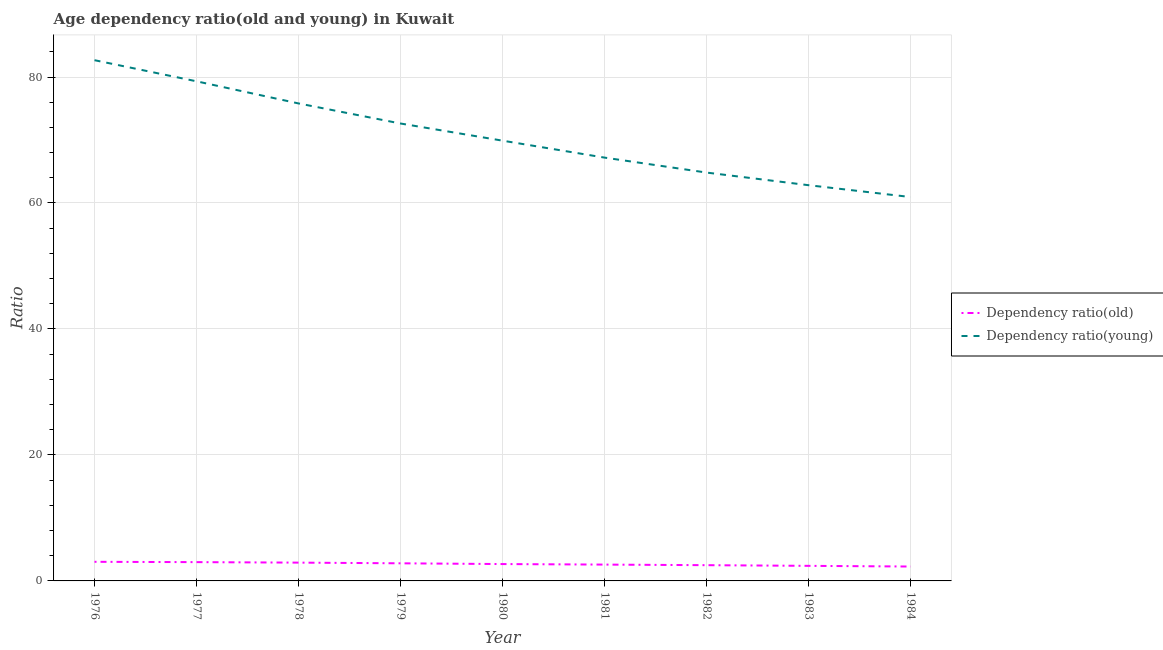How many different coloured lines are there?
Provide a short and direct response. 2. Does the line corresponding to age dependency ratio(old) intersect with the line corresponding to age dependency ratio(young)?
Your answer should be very brief. No. Is the number of lines equal to the number of legend labels?
Your answer should be very brief. Yes. What is the age dependency ratio(old) in 1978?
Your answer should be compact. 2.9. Across all years, what is the maximum age dependency ratio(young)?
Provide a short and direct response. 82.67. Across all years, what is the minimum age dependency ratio(old)?
Offer a very short reply. 2.28. In which year was the age dependency ratio(young) maximum?
Keep it short and to the point. 1976. What is the total age dependency ratio(old) in the graph?
Ensure brevity in your answer.  24.17. What is the difference between the age dependency ratio(old) in 1976 and that in 1982?
Ensure brevity in your answer.  0.54. What is the difference between the age dependency ratio(old) in 1979 and the age dependency ratio(young) in 1982?
Offer a very short reply. -62.03. What is the average age dependency ratio(young) per year?
Ensure brevity in your answer.  70.68. In the year 1983, what is the difference between the age dependency ratio(young) and age dependency ratio(old)?
Your answer should be very brief. 60.43. What is the ratio of the age dependency ratio(old) in 1979 to that in 1981?
Your answer should be compact. 1.08. Is the difference between the age dependency ratio(old) in 1981 and 1982 greater than the difference between the age dependency ratio(young) in 1981 and 1982?
Keep it short and to the point. No. What is the difference between the highest and the second highest age dependency ratio(old)?
Your answer should be compact. 0.05. What is the difference between the highest and the lowest age dependency ratio(old)?
Offer a terse response. 0.75. Is the age dependency ratio(old) strictly less than the age dependency ratio(young) over the years?
Provide a succinct answer. Yes. How many lines are there?
Offer a terse response. 2. How many years are there in the graph?
Your answer should be compact. 9. What is the difference between two consecutive major ticks on the Y-axis?
Your answer should be compact. 20. Are the values on the major ticks of Y-axis written in scientific E-notation?
Make the answer very short. No. Does the graph contain grids?
Ensure brevity in your answer.  Yes. Where does the legend appear in the graph?
Provide a succinct answer. Center right. What is the title of the graph?
Your response must be concise. Age dependency ratio(old and young) in Kuwait. Does "Primary" appear as one of the legend labels in the graph?
Ensure brevity in your answer.  No. What is the label or title of the Y-axis?
Offer a very short reply. Ratio. What is the Ratio of Dependency ratio(old) in 1976?
Your response must be concise. 3.03. What is the Ratio of Dependency ratio(young) in 1976?
Offer a terse response. 82.67. What is the Ratio of Dependency ratio(old) in 1977?
Offer a terse response. 2.98. What is the Ratio in Dependency ratio(young) in 1977?
Your answer should be compact. 79.32. What is the Ratio of Dependency ratio(old) in 1978?
Ensure brevity in your answer.  2.9. What is the Ratio in Dependency ratio(young) in 1978?
Your response must be concise. 75.8. What is the Ratio in Dependency ratio(old) in 1979?
Keep it short and to the point. 2.8. What is the Ratio of Dependency ratio(young) in 1979?
Provide a short and direct response. 72.62. What is the Ratio in Dependency ratio(old) in 1980?
Offer a terse response. 2.68. What is the Ratio in Dependency ratio(young) in 1980?
Your answer should be very brief. 69.89. What is the Ratio of Dependency ratio(old) in 1981?
Give a very brief answer. 2.59. What is the Ratio in Dependency ratio(young) in 1981?
Offer a very short reply. 67.2. What is the Ratio in Dependency ratio(old) in 1982?
Offer a very short reply. 2.5. What is the Ratio of Dependency ratio(young) in 1982?
Give a very brief answer. 64.83. What is the Ratio in Dependency ratio(old) in 1983?
Provide a succinct answer. 2.39. What is the Ratio of Dependency ratio(young) in 1983?
Your answer should be very brief. 62.82. What is the Ratio in Dependency ratio(old) in 1984?
Offer a terse response. 2.28. What is the Ratio in Dependency ratio(young) in 1984?
Provide a succinct answer. 60.94. Across all years, what is the maximum Ratio of Dependency ratio(old)?
Your answer should be very brief. 3.03. Across all years, what is the maximum Ratio in Dependency ratio(young)?
Offer a terse response. 82.67. Across all years, what is the minimum Ratio of Dependency ratio(old)?
Offer a very short reply. 2.28. Across all years, what is the minimum Ratio in Dependency ratio(young)?
Offer a very short reply. 60.94. What is the total Ratio of Dependency ratio(old) in the graph?
Ensure brevity in your answer.  24.17. What is the total Ratio in Dependency ratio(young) in the graph?
Provide a succinct answer. 636.1. What is the difference between the Ratio in Dependency ratio(old) in 1976 and that in 1977?
Make the answer very short. 0.05. What is the difference between the Ratio of Dependency ratio(young) in 1976 and that in 1977?
Provide a short and direct response. 3.35. What is the difference between the Ratio of Dependency ratio(old) in 1976 and that in 1978?
Offer a terse response. 0.13. What is the difference between the Ratio in Dependency ratio(young) in 1976 and that in 1978?
Your answer should be very brief. 6.87. What is the difference between the Ratio in Dependency ratio(old) in 1976 and that in 1979?
Ensure brevity in your answer.  0.24. What is the difference between the Ratio in Dependency ratio(young) in 1976 and that in 1979?
Your response must be concise. 10.05. What is the difference between the Ratio in Dependency ratio(old) in 1976 and that in 1980?
Offer a very short reply. 0.36. What is the difference between the Ratio of Dependency ratio(young) in 1976 and that in 1980?
Make the answer very short. 12.78. What is the difference between the Ratio in Dependency ratio(old) in 1976 and that in 1981?
Your answer should be very brief. 0.44. What is the difference between the Ratio in Dependency ratio(young) in 1976 and that in 1981?
Offer a terse response. 15.47. What is the difference between the Ratio of Dependency ratio(old) in 1976 and that in 1982?
Provide a succinct answer. 0.54. What is the difference between the Ratio of Dependency ratio(young) in 1976 and that in 1982?
Ensure brevity in your answer.  17.84. What is the difference between the Ratio of Dependency ratio(old) in 1976 and that in 1983?
Provide a short and direct response. 0.64. What is the difference between the Ratio in Dependency ratio(young) in 1976 and that in 1983?
Provide a succinct answer. 19.85. What is the difference between the Ratio of Dependency ratio(old) in 1976 and that in 1984?
Your answer should be compact. 0.75. What is the difference between the Ratio in Dependency ratio(young) in 1976 and that in 1984?
Your answer should be very brief. 21.73. What is the difference between the Ratio of Dependency ratio(old) in 1977 and that in 1978?
Your response must be concise. 0.08. What is the difference between the Ratio of Dependency ratio(young) in 1977 and that in 1978?
Your response must be concise. 3.51. What is the difference between the Ratio in Dependency ratio(old) in 1977 and that in 1979?
Your answer should be compact. 0.19. What is the difference between the Ratio of Dependency ratio(young) in 1977 and that in 1979?
Offer a very short reply. 6.7. What is the difference between the Ratio of Dependency ratio(old) in 1977 and that in 1980?
Provide a short and direct response. 0.31. What is the difference between the Ratio in Dependency ratio(young) in 1977 and that in 1980?
Provide a succinct answer. 9.42. What is the difference between the Ratio in Dependency ratio(old) in 1977 and that in 1981?
Your response must be concise. 0.39. What is the difference between the Ratio of Dependency ratio(young) in 1977 and that in 1981?
Keep it short and to the point. 12.11. What is the difference between the Ratio in Dependency ratio(old) in 1977 and that in 1982?
Make the answer very short. 0.48. What is the difference between the Ratio of Dependency ratio(young) in 1977 and that in 1982?
Provide a succinct answer. 14.49. What is the difference between the Ratio in Dependency ratio(old) in 1977 and that in 1983?
Offer a terse response. 0.59. What is the difference between the Ratio of Dependency ratio(young) in 1977 and that in 1983?
Offer a very short reply. 16.49. What is the difference between the Ratio in Dependency ratio(old) in 1977 and that in 1984?
Make the answer very short. 0.7. What is the difference between the Ratio in Dependency ratio(young) in 1977 and that in 1984?
Your answer should be very brief. 18.37. What is the difference between the Ratio of Dependency ratio(old) in 1978 and that in 1979?
Ensure brevity in your answer.  0.11. What is the difference between the Ratio of Dependency ratio(young) in 1978 and that in 1979?
Provide a succinct answer. 3.19. What is the difference between the Ratio of Dependency ratio(old) in 1978 and that in 1980?
Make the answer very short. 0.23. What is the difference between the Ratio in Dependency ratio(young) in 1978 and that in 1980?
Make the answer very short. 5.91. What is the difference between the Ratio in Dependency ratio(old) in 1978 and that in 1981?
Provide a succinct answer. 0.31. What is the difference between the Ratio in Dependency ratio(young) in 1978 and that in 1981?
Your answer should be compact. 8.6. What is the difference between the Ratio of Dependency ratio(old) in 1978 and that in 1982?
Keep it short and to the point. 0.41. What is the difference between the Ratio of Dependency ratio(young) in 1978 and that in 1982?
Provide a succinct answer. 10.98. What is the difference between the Ratio in Dependency ratio(old) in 1978 and that in 1983?
Your answer should be compact. 0.51. What is the difference between the Ratio of Dependency ratio(young) in 1978 and that in 1983?
Offer a very short reply. 12.98. What is the difference between the Ratio in Dependency ratio(old) in 1978 and that in 1984?
Offer a terse response. 0.62. What is the difference between the Ratio in Dependency ratio(young) in 1978 and that in 1984?
Your response must be concise. 14.86. What is the difference between the Ratio in Dependency ratio(old) in 1979 and that in 1980?
Ensure brevity in your answer.  0.12. What is the difference between the Ratio of Dependency ratio(young) in 1979 and that in 1980?
Your answer should be compact. 2.72. What is the difference between the Ratio of Dependency ratio(old) in 1979 and that in 1981?
Your response must be concise. 0.2. What is the difference between the Ratio of Dependency ratio(young) in 1979 and that in 1981?
Make the answer very short. 5.41. What is the difference between the Ratio in Dependency ratio(old) in 1979 and that in 1982?
Your answer should be very brief. 0.3. What is the difference between the Ratio of Dependency ratio(young) in 1979 and that in 1982?
Give a very brief answer. 7.79. What is the difference between the Ratio of Dependency ratio(old) in 1979 and that in 1983?
Your response must be concise. 0.4. What is the difference between the Ratio of Dependency ratio(young) in 1979 and that in 1983?
Offer a very short reply. 9.79. What is the difference between the Ratio of Dependency ratio(old) in 1979 and that in 1984?
Your response must be concise. 0.51. What is the difference between the Ratio in Dependency ratio(young) in 1979 and that in 1984?
Provide a succinct answer. 11.67. What is the difference between the Ratio of Dependency ratio(old) in 1980 and that in 1981?
Provide a succinct answer. 0.08. What is the difference between the Ratio of Dependency ratio(young) in 1980 and that in 1981?
Give a very brief answer. 2.69. What is the difference between the Ratio of Dependency ratio(old) in 1980 and that in 1982?
Give a very brief answer. 0.18. What is the difference between the Ratio in Dependency ratio(young) in 1980 and that in 1982?
Provide a succinct answer. 5.06. What is the difference between the Ratio of Dependency ratio(old) in 1980 and that in 1983?
Offer a terse response. 0.28. What is the difference between the Ratio in Dependency ratio(young) in 1980 and that in 1983?
Make the answer very short. 7.07. What is the difference between the Ratio in Dependency ratio(old) in 1980 and that in 1984?
Your response must be concise. 0.39. What is the difference between the Ratio of Dependency ratio(young) in 1980 and that in 1984?
Provide a short and direct response. 8.95. What is the difference between the Ratio in Dependency ratio(old) in 1981 and that in 1982?
Make the answer very short. 0.09. What is the difference between the Ratio in Dependency ratio(young) in 1981 and that in 1982?
Provide a short and direct response. 2.37. What is the difference between the Ratio of Dependency ratio(old) in 1981 and that in 1983?
Offer a terse response. 0.2. What is the difference between the Ratio in Dependency ratio(young) in 1981 and that in 1983?
Keep it short and to the point. 4.38. What is the difference between the Ratio of Dependency ratio(old) in 1981 and that in 1984?
Offer a very short reply. 0.31. What is the difference between the Ratio of Dependency ratio(young) in 1981 and that in 1984?
Your answer should be very brief. 6.26. What is the difference between the Ratio of Dependency ratio(old) in 1982 and that in 1983?
Give a very brief answer. 0.11. What is the difference between the Ratio in Dependency ratio(young) in 1982 and that in 1983?
Make the answer very short. 2. What is the difference between the Ratio in Dependency ratio(old) in 1982 and that in 1984?
Offer a very short reply. 0.21. What is the difference between the Ratio in Dependency ratio(young) in 1982 and that in 1984?
Your response must be concise. 3.88. What is the difference between the Ratio in Dependency ratio(old) in 1983 and that in 1984?
Ensure brevity in your answer.  0.11. What is the difference between the Ratio in Dependency ratio(young) in 1983 and that in 1984?
Ensure brevity in your answer.  1.88. What is the difference between the Ratio of Dependency ratio(old) in 1976 and the Ratio of Dependency ratio(young) in 1977?
Your answer should be very brief. -76.28. What is the difference between the Ratio in Dependency ratio(old) in 1976 and the Ratio in Dependency ratio(young) in 1978?
Provide a succinct answer. -72.77. What is the difference between the Ratio in Dependency ratio(old) in 1976 and the Ratio in Dependency ratio(young) in 1979?
Ensure brevity in your answer.  -69.58. What is the difference between the Ratio in Dependency ratio(old) in 1976 and the Ratio in Dependency ratio(young) in 1980?
Your response must be concise. -66.86. What is the difference between the Ratio in Dependency ratio(old) in 1976 and the Ratio in Dependency ratio(young) in 1981?
Make the answer very short. -64.17. What is the difference between the Ratio in Dependency ratio(old) in 1976 and the Ratio in Dependency ratio(young) in 1982?
Make the answer very short. -61.79. What is the difference between the Ratio in Dependency ratio(old) in 1976 and the Ratio in Dependency ratio(young) in 1983?
Provide a short and direct response. -59.79. What is the difference between the Ratio in Dependency ratio(old) in 1976 and the Ratio in Dependency ratio(young) in 1984?
Keep it short and to the point. -57.91. What is the difference between the Ratio of Dependency ratio(old) in 1977 and the Ratio of Dependency ratio(young) in 1978?
Offer a terse response. -72.82. What is the difference between the Ratio in Dependency ratio(old) in 1977 and the Ratio in Dependency ratio(young) in 1979?
Offer a terse response. -69.64. What is the difference between the Ratio in Dependency ratio(old) in 1977 and the Ratio in Dependency ratio(young) in 1980?
Your answer should be compact. -66.91. What is the difference between the Ratio in Dependency ratio(old) in 1977 and the Ratio in Dependency ratio(young) in 1981?
Ensure brevity in your answer.  -64.22. What is the difference between the Ratio of Dependency ratio(old) in 1977 and the Ratio of Dependency ratio(young) in 1982?
Keep it short and to the point. -61.85. What is the difference between the Ratio in Dependency ratio(old) in 1977 and the Ratio in Dependency ratio(young) in 1983?
Your response must be concise. -59.84. What is the difference between the Ratio of Dependency ratio(old) in 1977 and the Ratio of Dependency ratio(young) in 1984?
Give a very brief answer. -57.96. What is the difference between the Ratio in Dependency ratio(old) in 1978 and the Ratio in Dependency ratio(young) in 1979?
Provide a short and direct response. -69.71. What is the difference between the Ratio in Dependency ratio(old) in 1978 and the Ratio in Dependency ratio(young) in 1980?
Make the answer very short. -66.99. What is the difference between the Ratio in Dependency ratio(old) in 1978 and the Ratio in Dependency ratio(young) in 1981?
Offer a very short reply. -64.3. What is the difference between the Ratio in Dependency ratio(old) in 1978 and the Ratio in Dependency ratio(young) in 1982?
Give a very brief answer. -61.92. What is the difference between the Ratio of Dependency ratio(old) in 1978 and the Ratio of Dependency ratio(young) in 1983?
Ensure brevity in your answer.  -59.92. What is the difference between the Ratio in Dependency ratio(old) in 1978 and the Ratio in Dependency ratio(young) in 1984?
Ensure brevity in your answer.  -58.04. What is the difference between the Ratio of Dependency ratio(old) in 1979 and the Ratio of Dependency ratio(young) in 1980?
Offer a terse response. -67.1. What is the difference between the Ratio of Dependency ratio(old) in 1979 and the Ratio of Dependency ratio(young) in 1981?
Offer a very short reply. -64.41. What is the difference between the Ratio in Dependency ratio(old) in 1979 and the Ratio in Dependency ratio(young) in 1982?
Your answer should be very brief. -62.03. What is the difference between the Ratio in Dependency ratio(old) in 1979 and the Ratio in Dependency ratio(young) in 1983?
Keep it short and to the point. -60.03. What is the difference between the Ratio of Dependency ratio(old) in 1979 and the Ratio of Dependency ratio(young) in 1984?
Offer a terse response. -58.15. What is the difference between the Ratio of Dependency ratio(old) in 1980 and the Ratio of Dependency ratio(young) in 1981?
Your answer should be compact. -64.53. What is the difference between the Ratio in Dependency ratio(old) in 1980 and the Ratio in Dependency ratio(young) in 1982?
Provide a short and direct response. -62.15. What is the difference between the Ratio in Dependency ratio(old) in 1980 and the Ratio in Dependency ratio(young) in 1983?
Your response must be concise. -60.15. What is the difference between the Ratio in Dependency ratio(old) in 1980 and the Ratio in Dependency ratio(young) in 1984?
Your answer should be compact. -58.27. What is the difference between the Ratio of Dependency ratio(old) in 1981 and the Ratio of Dependency ratio(young) in 1982?
Ensure brevity in your answer.  -62.24. What is the difference between the Ratio in Dependency ratio(old) in 1981 and the Ratio in Dependency ratio(young) in 1983?
Ensure brevity in your answer.  -60.23. What is the difference between the Ratio in Dependency ratio(old) in 1981 and the Ratio in Dependency ratio(young) in 1984?
Your response must be concise. -58.35. What is the difference between the Ratio in Dependency ratio(old) in 1982 and the Ratio in Dependency ratio(young) in 1983?
Offer a terse response. -60.32. What is the difference between the Ratio of Dependency ratio(old) in 1982 and the Ratio of Dependency ratio(young) in 1984?
Your response must be concise. -58.45. What is the difference between the Ratio of Dependency ratio(old) in 1983 and the Ratio of Dependency ratio(young) in 1984?
Provide a short and direct response. -58.55. What is the average Ratio in Dependency ratio(old) per year?
Keep it short and to the point. 2.69. What is the average Ratio of Dependency ratio(young) per year?
Your answer should be compact. 70.68. In the year 1976, what is the difference between the Ratio of Dependency ratio(old) and Ratio of Dependency ratio(young)?
Give a very brief answer. -79.64. In the year 1977, what is the difference between the Ratio of Dependency ratio(old) and Ratio of Dependency ratio(young)?
Ensure brevity in your answer.  -76.33. In the year 1978, what is the difference between the Ratio of Dependency ratio(old) and Ratio of Dependency ratio(young)?
Offer a terse response. -72.9. In the year 1979, what is the difference between the Ratio of Dependency ratio(old) and Ratio of Dependency ratio(young)?
Give a very brief answer. -69.82. In the year 1980, what is the difference between the Ratio of Dependency ratio(old) and Ratio of Dependency ratio(young)?
Offer a terse response. -67.22. In the year 1981, what is the difference between the Ratio of Dependency ratio(old) and Ratio of Dependency ratio(young)?
Your answer should be very brief. -64.61. In the year 1982, what is the difference between the Ratio in Dependency ratio(old) and Ratio in Dependency ratio(young)?
Keep it short and to the point. -62.33. In the year 1983, what is the difference between the Ratio of Dependency ratio(old) and Ratio of Dependency ratio(young)?
Your answer should be compact. -60.43. In the year 1984, what is the difference between the Ratio of Dependency ratio(old) and Ratio of Dependency ratio(young)?
Offer a very short reply. -58.66. What is the ratio of the Ratio of Dependency ratio(old) in 1976 to that in 1977?
Provide a succinct answer. 1.02. What is the ratio of the Ratio of Dependency ratio(young) in 1976 to that in 1977?
Give a very brief answer. 1.04. What is the ratio of the Ratio of Dependency ratio(old) in 1976 to that in 1978?
Ensure brevity in your answer.  1.04. What is the ratio of the Ratio of Dependency ratio(young) in 1976 to that in 1978?
Offer a very short reply. 1.09. What is the ratio of the Ratio in Dependency ratio(old) in 1976 to that in 1979?
Give a very brief answer. 1.09. What is the ratio of the Ratio of Dependency ratio(young) in 1976 to that in 1979?
Offer a very short reply. 1.14. What is the ratio of the Ratio in Dependency ratio(old) in 1976 to that in 1980?
Ensure brevity in your answer.  1.13. What is the ratio of the Ratio in Dependency ratio(young) in 1976 to that in 1980?
Provide a succinct answer. 1.18. What is the ratio of the Ratio in Dependency ratio(old) in 1976 to that in 1981?
Your answer should be very brief. 1.17. What is the ratio of the Ratio of Dependency ratio(young) in 1976 to that in 1981?
Your response must be concise. 1.23. What is the ratio of the Ratio in Dependency ratio(old) in 1976 to that in 1982?
Make the answer very short. 1.21. What is the ratio of the Ratio of Dependency ratio(young) in 1976 to that in 1982?
Provide a short and direct response. 1.28. What is the ratio of the Ratio of Dependency ratio(old) in 1976 to that in 1983?
Make the answer very short. 1.27. What is the ratio of the Ratio of Dependency ratio(young) in 1976 to that in 1983?
Offer a terse response. 1.32. What is the ratio of the Ratio in Dependency ratio(old) in 1976 to that in 1984?
Make the answer very short. 1.33. What is the ratio of the Ratio in Dependency ratio(young) in 1976 to that in 1984?
Offer a very short reply. 1.36. What is the ratio of the Ratio of Dependency ratio(old) in 1977 to that in 1978?
Keep it short and to the point. 1.03. What is the ratio of the Ratio in Dependency ratio(young) in 1977 to that in 1978?
Provide a succinct answer. 1.05. What is the ratio of the Ratio in Dependency ratio(old) in 1977 to that in 1979?
Offer a terse response. 1.07. What is the ratio of the Ratio of Dependency ratio(young) in 1977 to that in 1979?
Make the answer very short. 1.09. What is the ratio of the Ratio in Dependency ratio(old) in 1977 to that in 1980?
Provide a short and direct response. 1.11. What is the ratio of the Ratio in Dependency ratio(young) in 1977 to that in 1980?
Your answer should be compact. 1.13. What is the ratio of the Ratio in Dependency ratio(old) in 1977 to that in 1981?
Give a very brief answer. 1.15. What is the ratio of the Ratio of Dependency ratio(young) in 1977 to that in 1981?
Give a very brief answer. 1.18. What is the ratio of the Ratio in Dependency ratio(old) in 1977 to that in 1982?
Your answer should be compact. 1.19. What is the ratio of the Ratio in Dependency ratio(young) in 1977 to that in 1982?
Give a very brief answer. 1.22. What is the ratio of the Ratio in Dependency ratio(old) in 1977 to that in 1983?
Your answer should be very brief. 1.25. What is the ratio of the Ratio of Dependency ratio(young) in 1977 to that in 1983?
Give a very brief answer. 1.26. What is the ratio of the Ratio in Dependency ratio(old) in 1977 to that in 1984?
Provide a short and direct response. 1.31. What is the ratio of the Ratio in Dependency ratio(young) in 1977 to that in 1984?
Provide a succinct answer. 1.3. What is the ratio of the Ratio of Dependency ratio(old) in 1978 to that in 1979?
Keep it short and to the point. 1.04. What is the ratio of the Ratio of Dependency ratio(young) in 1978 to that in 1979?
Provide a succinct answer. 1.04. What is the ratio of the Ratio in Dependency ratio(old) in 1978 to that in 1980?
Keep it short and to the point. 1.09. What is the ratio of the Ratio in Dependency ratio(young) in 1978 to that in 1980?
Make the answer very short. 1.08. What is the ratio of the Ratio of Dependency ratio(old) in 1978 to that in 1981?
Your answer should be compact. 1.12. What is the ratio of the Ratio in Dependency ratio(young) in 1978 to that in 1981?
Give a very brief answer. 1.13. What is the ratio of the Ratio of Dependency ratio(old) in 1978 to that in 1982?
Your response must be concise. 1.16. What is the ratio of the Ratio in Dependency ratio(young) in 1978 to that in 1982?
Give a very brief answer. 1.17. What is the ratio of the Ratio of Dependency ratio(old) in 1978 to that in 1983?
Make the answer very short. 1.21. What is the ratio of the Ratio of Dependency ratio(young) in 1978 to that in 1983?
Ensure brevity in your answer.  1.21. What is the ratio of the Ratio of Dependency ratio(old) in 1978 to that in 1984?
Your response must be concise. 1.27. What is the ratio of the Ratio of Dependency ratio(young) in 1978 to that in 1984?
Offer a very short reply. 1.24. What is the ratio of the Ratio of Dependency ratio(old) in 1979 to that in 1980?
Give a very brief answer. 1.04. What is the ratio of the Ratio of Dependency ratio(young) in 1979 to that in 1980?
Offer a terse response. 1.04. What is the ratio of the Ratio of Dependency ratio(old) in 1979 to that in 1981?
Your answer should be compact. 1.08. What is the ratio of the Ratio of Dependency ratio(young) in 1979 to that in 1981?
Offer a very short reply. 1.08. What is the ratio of the Ratio of Dependency ratio(old) in 1979 to that in 1982?
Your answer should be very brief. 1.12. What is the ratio of the Ratio in Dependency ratio(young) in 1979 to that in 1982?
Provide a short and direct response. 1.12. What is the ratio of the Ratio in Dependency ratio(old) in 1979 to that in 1983?
Keep it short and to the point. 1.17. What is the ratio of the Ratio of Dependency ratio(young) in 1979 to that in 1983?
Ensure brevity in your answer.  1.16. What is the ratio of the Ratio in Dependency ratio(old) in 1979 to that in 1984?
Provide a short and direct response. 1.22. What is the ratio of the Ratio in Dependency ratio(young) in 1979 to that in 1984?
Your answer should be very brief. 1.19. What is the ratio of the Ratio of Dependency ratio(old) in 1980 to that in 1981?
Your answer should be very brief. 1.03. What is the ratio of the Ratio in Dependency ratio(young) in 1980 to that in 1981?
Provide a short and direct response. 1.04. What is the ratio of the Ratio in Dependency ratio(old) in 1980 to that in 1982?
Ensure brevity in your answer.  1.07. What is the ratio of the Ratio of Dependency ratio(young) in 1980 to that in 1982?
Ensure brevity in your answer.  1.08. What is the ratio of the Ratio of Dependency ratio(old) in 1980 to that in 1983?
Your answer should be very brief. 1.12. What is the ratio of the Ratio of Dependency ratio(young) in 1980 to that in 1983?
Offer a very short reply. 1.11. What is the ratio of the Ratio of Dependency ratio(old) in 1980 to that in 1984?
Provide a succinct answer. 1.17. What is the ratio of the Ratio in Dependency ratio(young) in 1980 to that in 1984?
Your response must be concise. 1.15. What is the ratio of the Ratio in Dependency ratio(old) in 1981 to that in 1982?
Keep it short and to the point. 1.04. What is the ratio of the Ratio of Dependency ratio(young) in 1981 to that in 1982?
Make the answer very short. 1.04. What is the ratio of the Ratio in Dependency ratio(old) in 1981 to that in 1983?
Your response must be concise. 1.08. What is the ratio of the Ratio of Dependency ratio(young) in 1981 to that in 1983?
Provide a short and direct response. 1.07. What is the ratio of the Ratio of Dependency ratio(old) in 1981 to that in 1984?
Your answer should be very brief. 1.14. What is the ratio of the Ratio in Dependency ratio(young) in 1981 to that in 1984?
Offer a very short reply. 1.1. What is the ratio of the Ratio in Dependency ratio(old) in 1982 to that in 1983?
Your answer should be very brief. 1.04. What is the ratio of the Ratio of Dependency ratio(young) in 1982 to that in 1983?
Provide a short and direct response. 1.03. What is the ratio of the Ratio of Dependency ratio(old) in 1982 to that in 1984?
Your answer should be compact. 1.09. What is the ratio of the Ratio of Dependency ratio(young) in 1982 to that in 1984?
Offer a very short reply. 1.06. What is the ratio of the Ratio of Dependency ratio(old) in 1983 to that in 1984?
Your response must be concise. 1.05. What is the ratio of the Ratio in Dependency ratio(young) in 1983 to that in 1984?
Your response must be concise. 1.03. What is the difference between the highest and the second highest Ratio of Dependency ratio(old)?
Provide a short and direct response. 0.05. What is the difference between the highest and the second highest Ratio of Dependency ratio(young)?
Your response must be concise. 3.35. What is the difference between the highest and the lowest Ratio of Dependency ratio(old)?
Make the answer very short. 0.75. What is the difference between the highest and the lowest Ratio in Dependency ratio(young)?
Your answer should be compact. 21.73. 